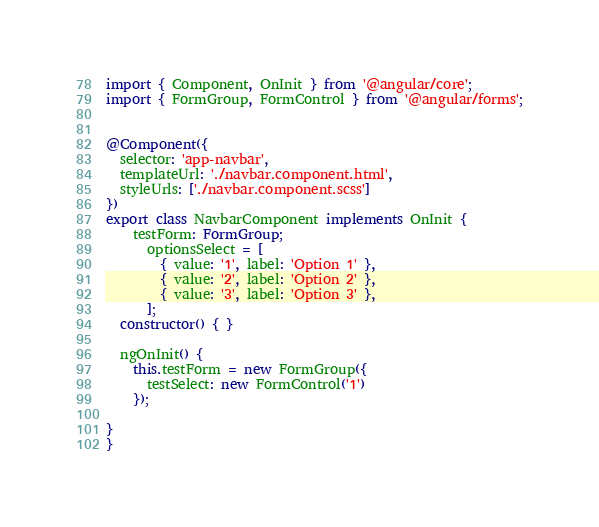<code> <loc_0><loc_0><loc_500><loc_500><_TypeScript_>import { Component, OnInit } from '@angular/core';
import { FormGroup, FormControl } from '@angular/forms';


@Component({
  selector: 'app-navbar',
  templateUrl: './navbar.component.html',
  styleUrls: ['./navbar.component.scss']
})
export class NavbarComponent implements OnInit {
	testForm: FormGroup;
	  optionsSelect = [
	    { value: '1', label: 'Option 1' },
	    { value: '2', label: 'Option 2' },
	    { value: '3', label: 'Option 3' },
	  ];
  constructor() { }

  ngOnInit() {
    this.testForm = new FormGroup({
      testSelect: new FormControl('1')
    });

}
}</code> 